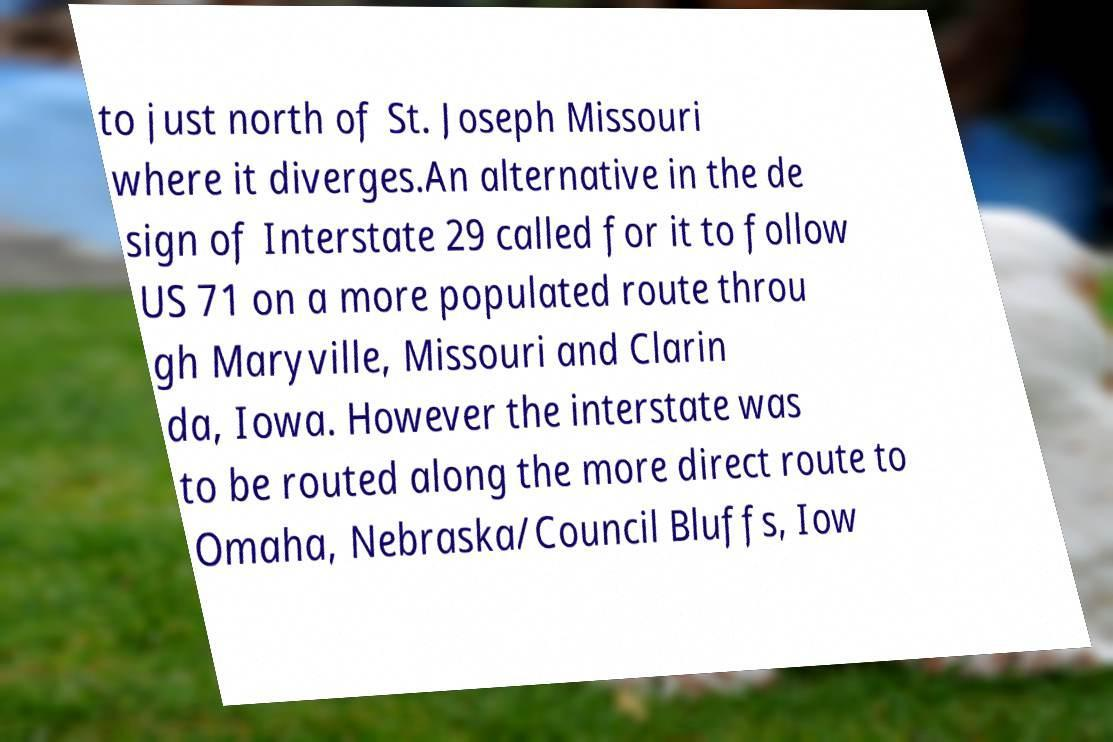Can you read and provide the text displayed in the image?This photo seems to have some interesting text. Can you extract and type it out for me? to just north of St. Joseph Missouri where it diverges.An alternative in the de sign of Interstate 29 called for it to follow US 71 on a more populated route throu gh Maryville, Missouri and Clarin da, Iowa. However the interstate was to be routed along the more direct route to Omaha, Nebraska/Council Bluffs, Iow 